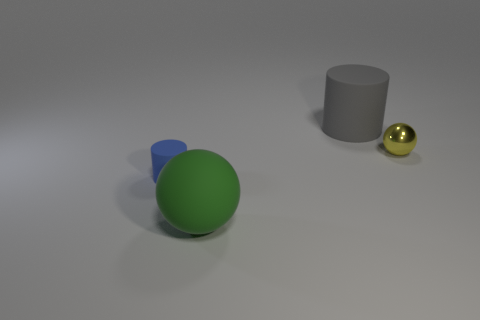Add 2 large red rubber balls. How many objects exist? 6 Subtract all cyan metal balls. Subtract all tiny metallic objects. How many objects are left? 3 Add 2 tiny things. How many tiny things are left? 4 Add 2 tiny yellow things. How many tiny yellow things exist? 3 Subtract 0 blue blocks. How many objects are left? 4 